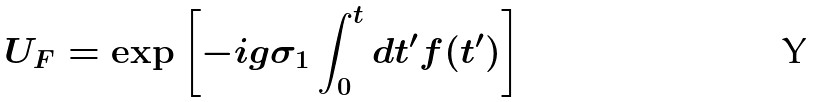Convert formula to latex. <formula><loc_0><loc_0><loc_500><loc_500>U _ { F } = \exp \left [ - i g \sigma _ { 1 } \int _ { 0 } ^ { t } d t ^ { \prime } f ( t ^ { \prime } ) \right ]</formula> 